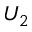<formula> <loc_0><loc_0><loc_500><loc_500>U _ { 2 }</formula> 